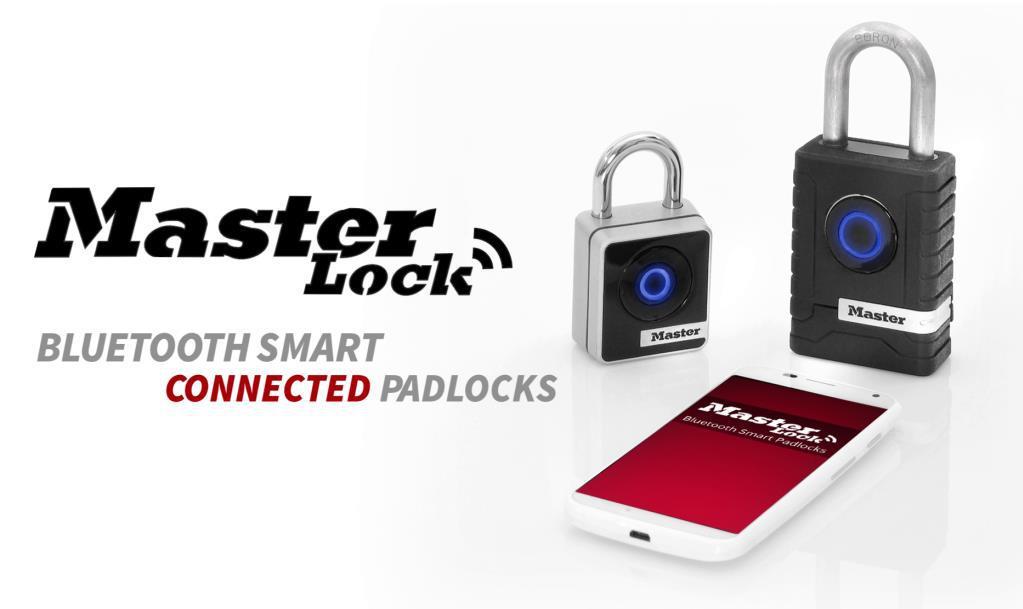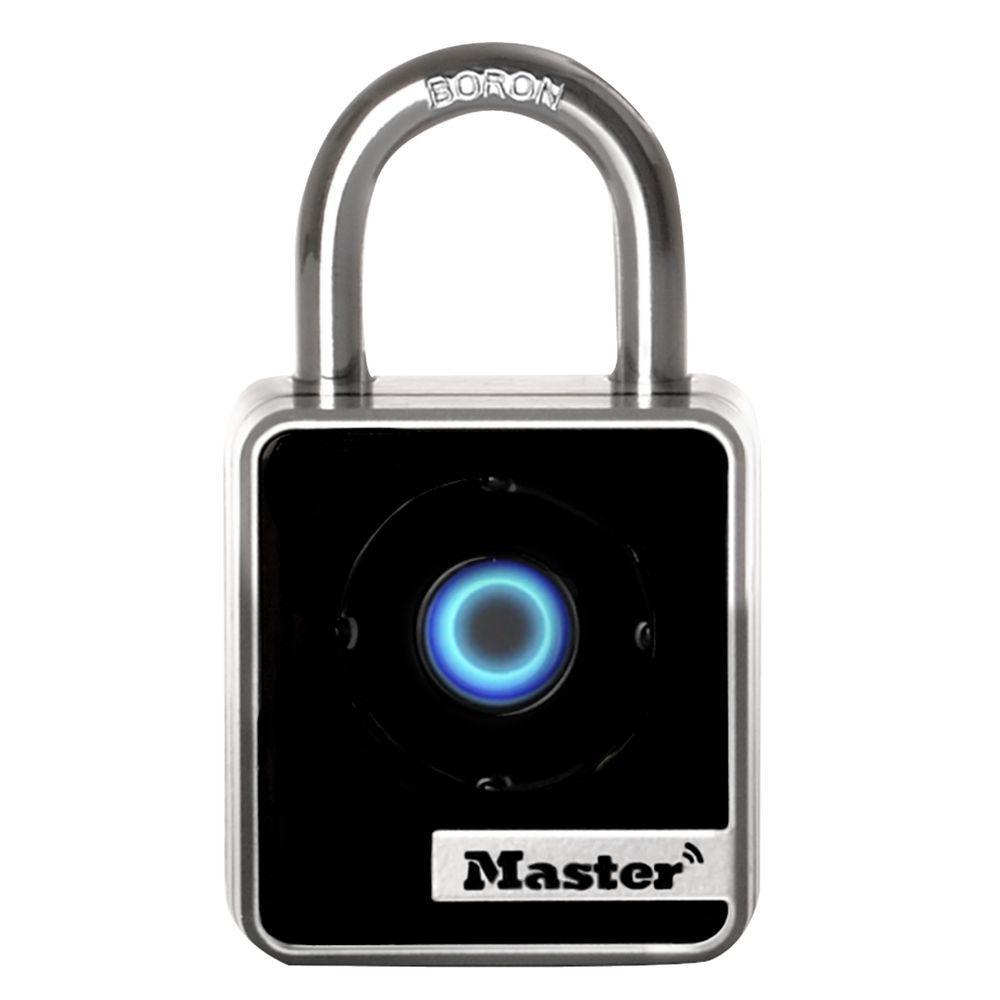The first image is the image on the left, the second image is the image on the right. For the images displayed, is the sentence "Each image contains just one lock, which is upright and has a blue circle on the front." factually correct? Answer yes or no. No. The first image is the image on the left, the second image is the image on the right. Analyze the images presented: Is the assertion "Exactly two locks are shown, both of them locked and with a circular design and logo on the front, one with ridges on each side." valid? Answer yes or no. No. 